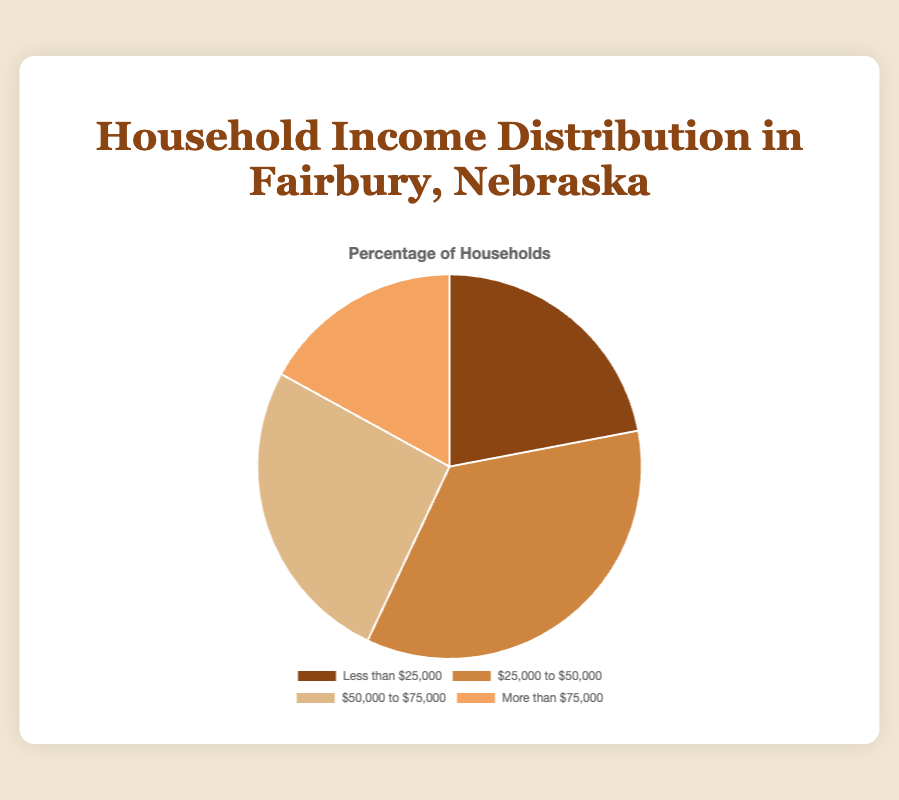What percentage of households in Fairbury have an income less than $25,000? According to the figure, 22% of households fall into the "Less than $25,000" income bracket.
Answer: 22% Which income bracket has the highest percentage of households? By observing the percentages, '$25,000 to $50,000' has the highest percentage at 35%.
Answer: $25,000 to $50,000 How much higher is the percentage of households earning $25,000 to $50,000 compared to those earning more than $75,000? The percentage for $25,000 to $50,000 is 35%, and for more than $75,000 is 17%. Subtracting 17 from 35 gives us 18%.
Answer: 18% What is the total percentage of households earning between $25,000 and $75,000? The figure shows 35% for $25,000 to $50,000 and 26% for $50,000 to $75,000. Adding these percentages gives 35 + 26 = 61%.
Answer: 61% What is the difference in percentage between the highest and lowest income brackets? The highest income bracket '$25,000 to $50,000' has 35%, and the lowest 'More than $75,000' has 17%. The difference is 35 - 17 = 18%.
Answer: 18% Which income bracket has the closest percentage to a quarter of all households in Fairbury? A quarter or 25% of households is closest to the 26% in the '$50,000 to $75,000' bracket.
Answer: $50,000 to $75,000 What percentage of households earn more than $50,000? Adding the percentages of $50,000 to $75,000 (26%) and more than $75,000 (17%) gives us 26 + 17 = 43%.
Answer: 43% How does the percentage of households earning less than $25,000 compare to those earning between $50,000 and $75,000? The "Less than $25,000" bracket is 22%, and the "$50,000 to $75,000" bracket is 26%. The latter is 4% higher.
Answer: 4% Which income bracket segment is represented by the darkest color on the chart? The segment 'Less than $25,000' is represented by the darkest color, which is brown.
Answer: Less than $25,000 What is the combined percentage of households earning less than $50,000? Adding the percentages of 'Less than $25,000' (22%) and '$25,000 to $50,000' (35%) gives 22 + 35 = 57%.
Answer: 57% 